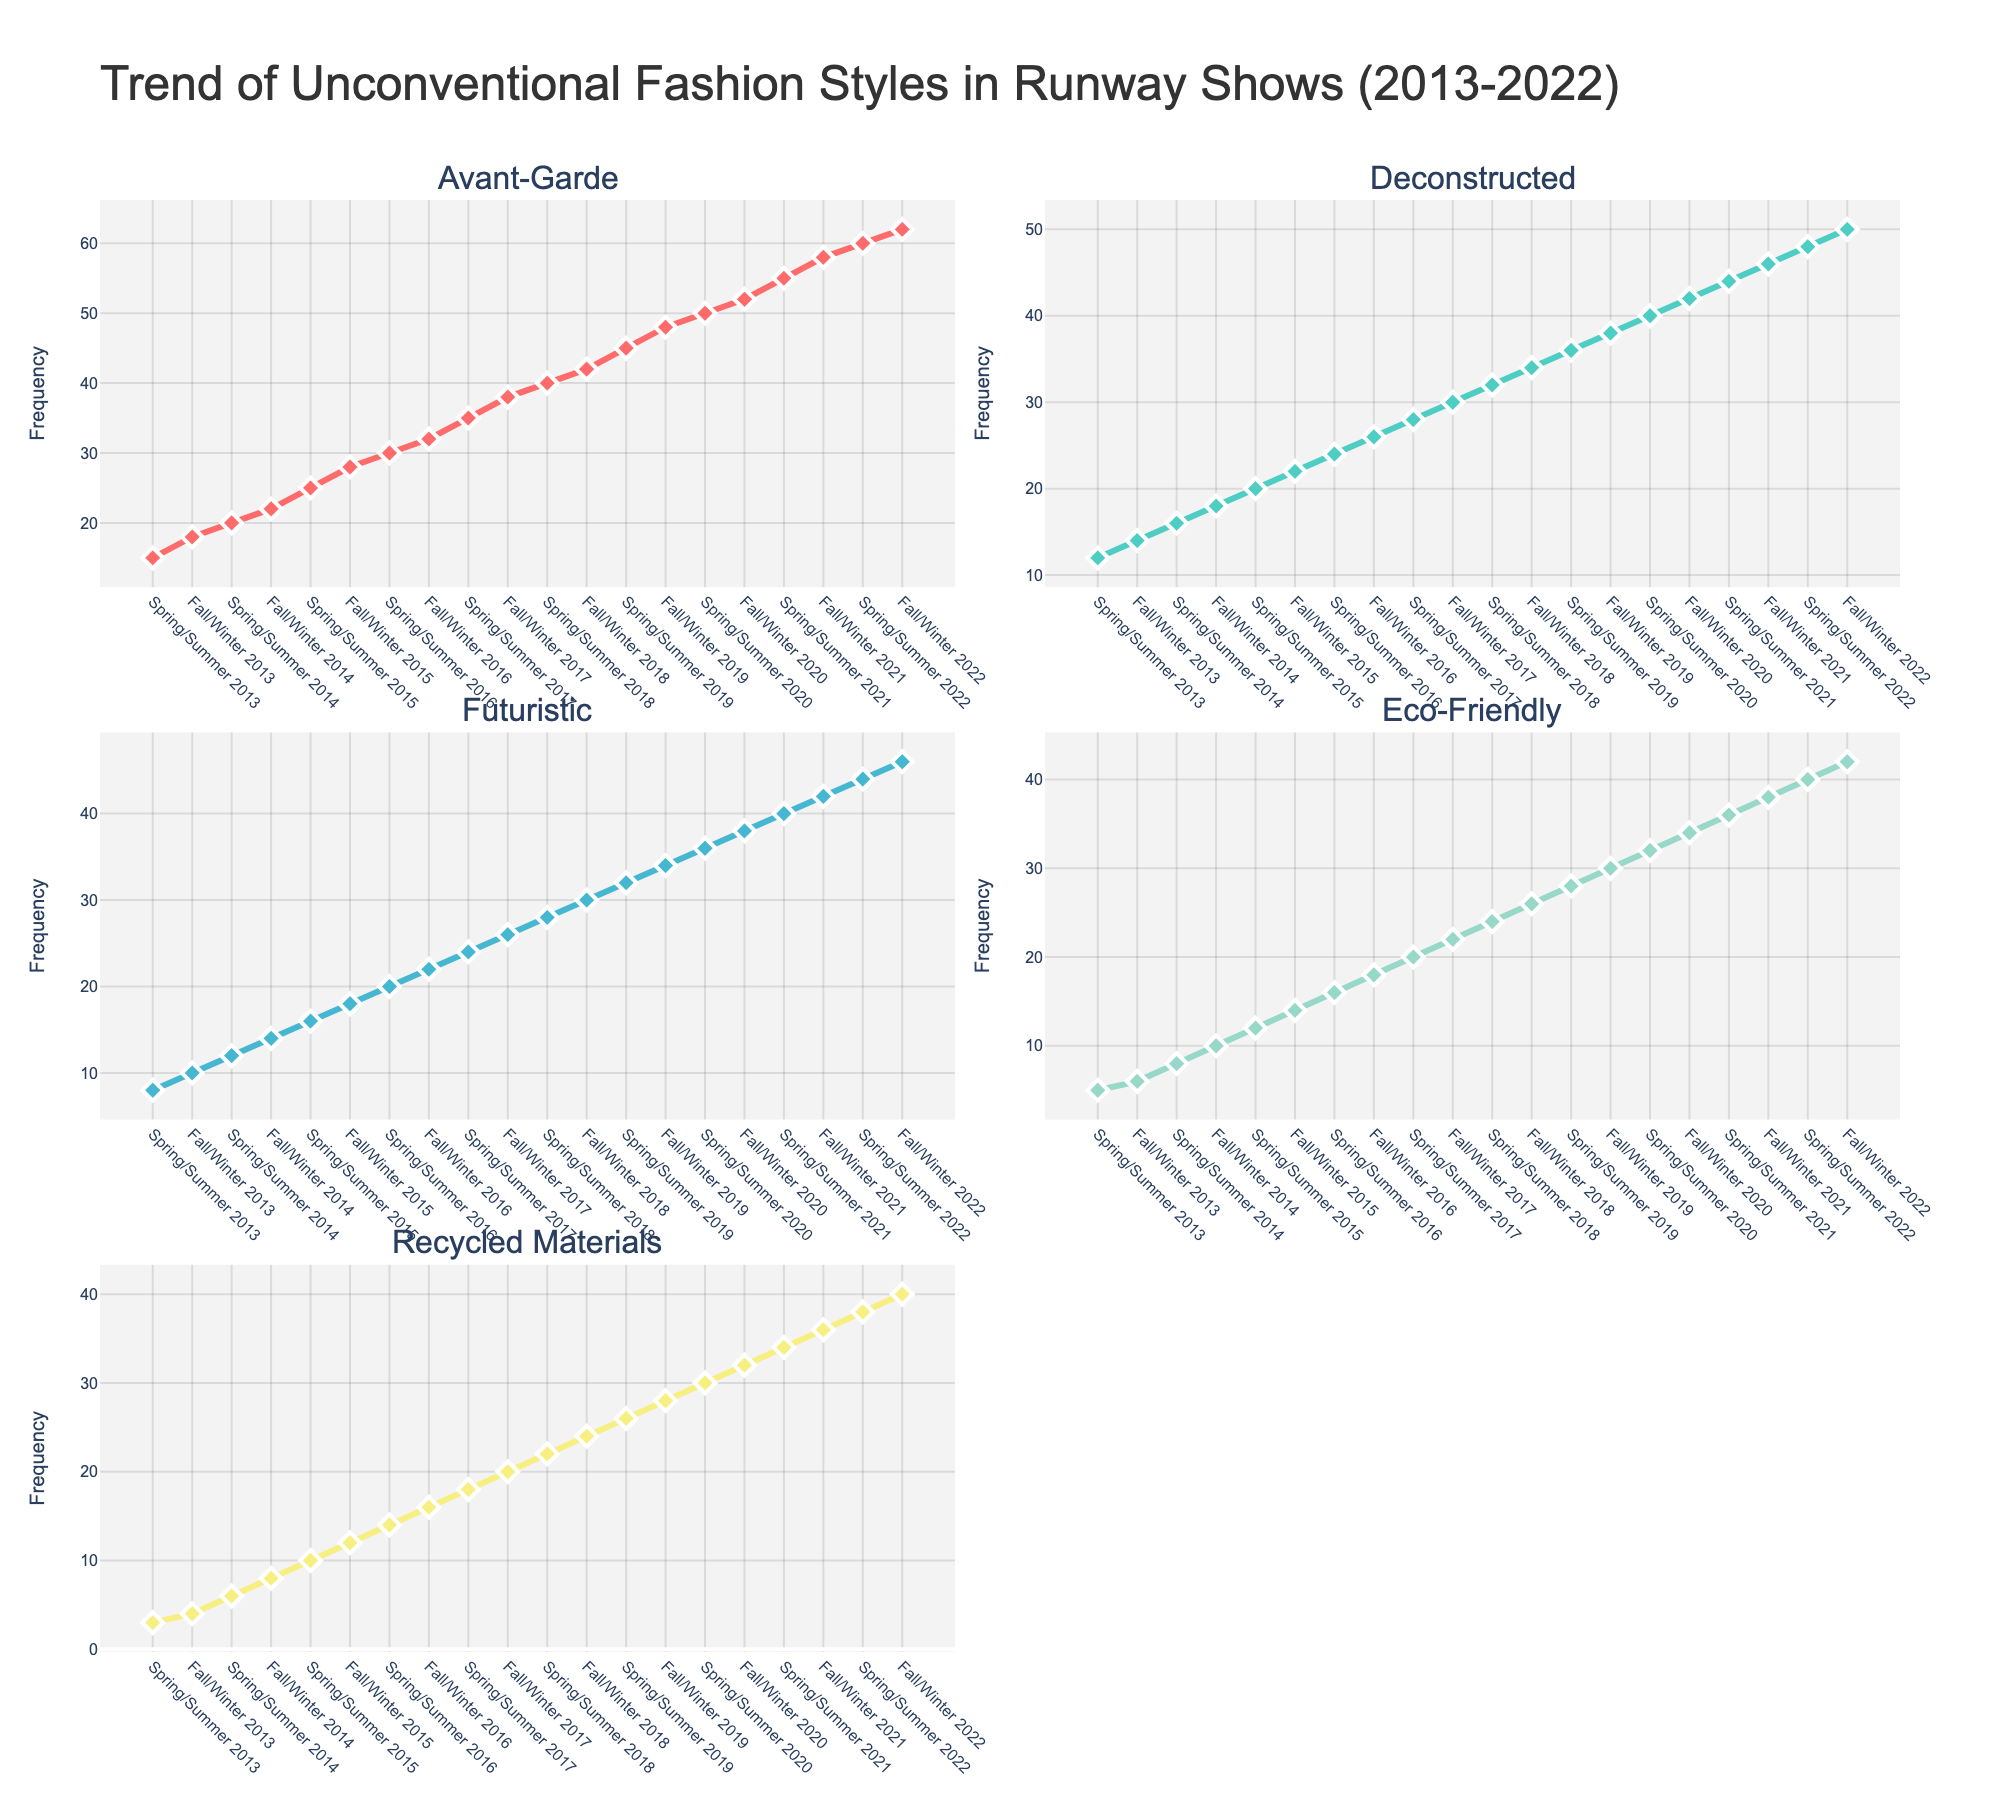How many styles are tracked in the plot? The subplot titles indicate five different fashion styles: Avant-Garde, Deconstructed, Futuristic, Eco-Friendly, and Recycled Materials.
Answer: 5 Which fashion style has the highest frequency in Fall/Winter 2022? By examining the points at Fall/Winter 2022 across the subplots, Avant-Garde has the highest frequency with a value of 62.
Answer: Avant-Garde What is the trend for Eco-Friendly fashion from 2013 to 2022? By following the line in the subplot for Eco-Friendly, it is apparent that the frequency increases consistently over time from 5 to 42.
Answer: Increasing Compare the frequency of Deconstructed fashion in Spring/Summer 2016 and Fall/Winter 2019. Which one is higher? In Spring/Summer 2016, the frequency is 24, and in Fall/Winter 2019, it is 38. Therefore, Fall/Winter 2019 is higher.
Answer: Fall/Winter 2019 What season and year show the highest frequency for Recycled Materials fashion style? By observing the Recycled Materials subplot, the highest frequency occurs in Fall/Winter 2022 with a value of 40.
Answer: Fall/Winter 2022 Calculate the difference in frequency between the Avant-Garde and Futuristic styles for Spring/Summer 2020. The Avant-Garde value is 50 and the Futuristic value is 36. The difference is 50 - 36 = 14.
Answer: 14 What is the average frequency of Futuristic styles in 2016? The frequencies for Futuristic in Spring/Summer 2016 and Fall/Winter 2016 are 20 and 22, respectively. The average is (20 + 22) / 2 = 21.
Answer: 21 Is there any style that does not show an increasing trend from 2013 to 2022? All the subplots show lines that consistently increase over time, indicating that all styles show an increasing trend.
Answer: No Which two styles have a similar frequency in Spring/Summer 2017? In Spring/Summer 2017, Deconstructed has a frequency of 28 and Futuristic has a frequency of 24, which are close.
Answer: Deconstructed and Futuristic Is the line for Eco-Friendly more or less steep than Recycled Materials from 2013 to 2022? Compared to Eco-Friendly, the line for Recycled Materials appears less steep, indicating a slower rate of increase.
Answer: Less steep 